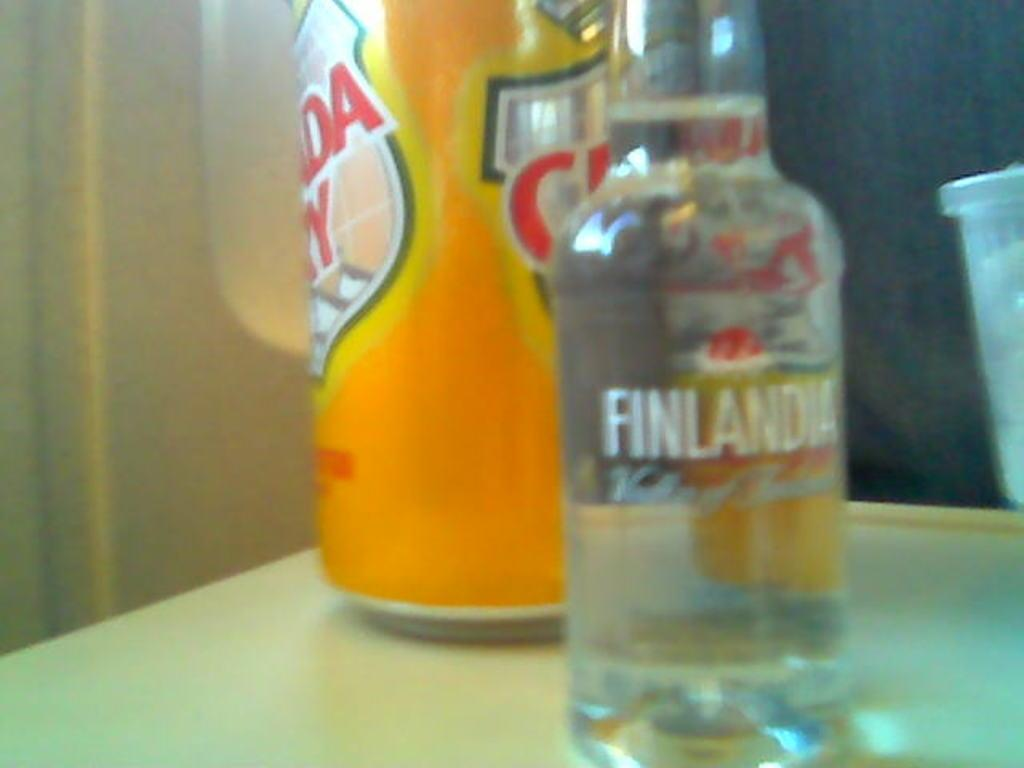<image>
Provide a brief description of the given image. A bottle of Finlandia alcohol in front of a can of Canada Dry soda. 